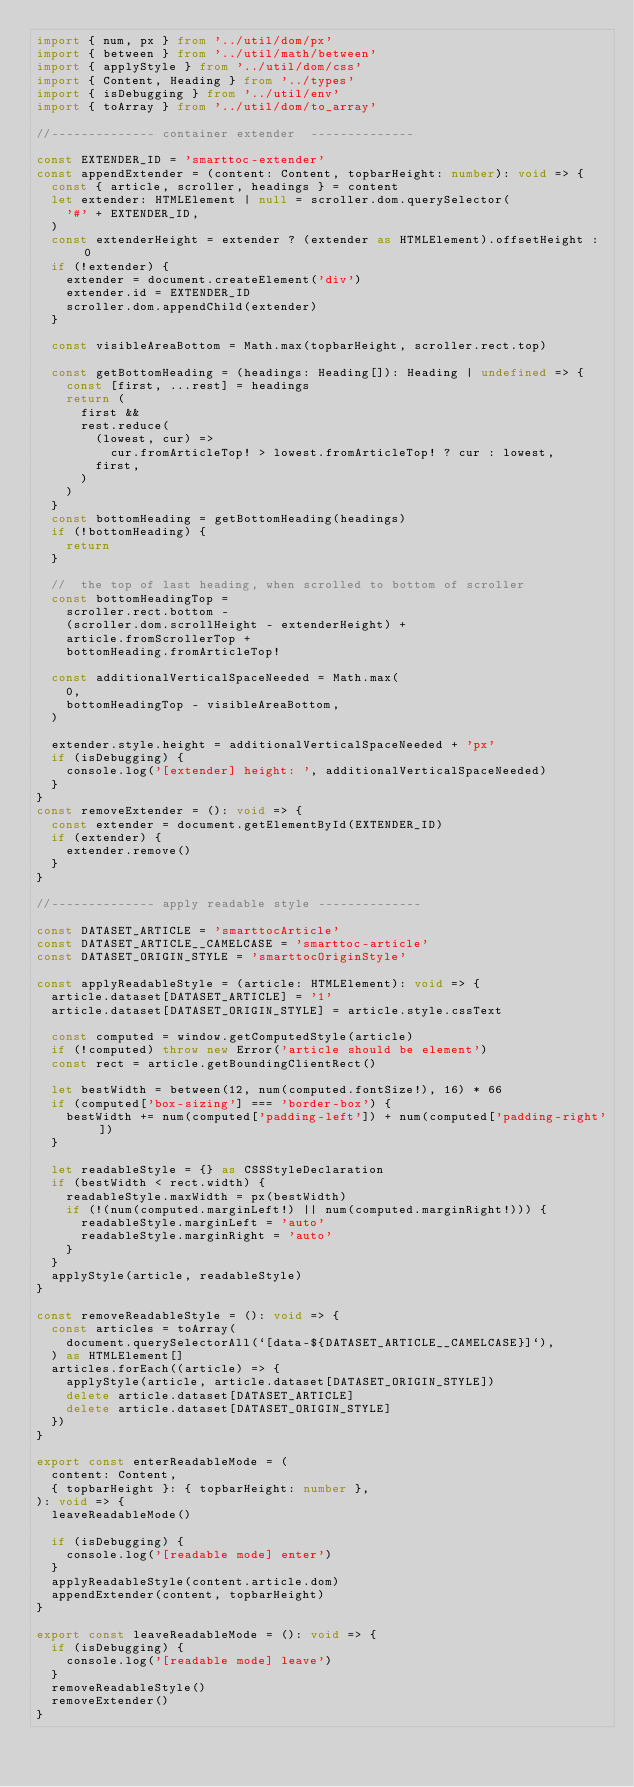Convert code to text. <code><loc_0><loc_0><loc_500><loc_500><_TypeScript_>import { num, px } from '../util/dom/px'
import { between } from '../util/math/between'
import { applyStyle } from '../util/dom/css'
import { Content, Heading } from '../types'
import { isDebugging } from '../util/env'
import { toArray } from '../util/dom/to_array'

//-------------- container extender  --------------

const EXTENDER_ID = 'smarttoc-extender'
const appendExtender = (content: Content, topbarHeight: number): void => {
  const { article, scroller, headings } = content
  let extender: HTMLElement | null = scroller.dom.querySelector(
    '#' + EXTENDER_ID,
  )
  const extenderHeight = extender ? (extender as HTMLElement).offsetHeight : 0
  if (!extender) {
    extender = document.createElement('div')
    extender.id = EXTENDER_ID
    scroller.dom.appendChild(extender)
  }

  const visibleAreaBottom = Math.max(topbarHeight, scroller.rect.top)

  const getBottomHeading = (headings: Heading[]): Heading | undefined => {
    const [first, ...rest] = headings
    return (
      first &&
      rest.reduce(
        (lowest, cur) =>
          cur.fromArticleTop! > lowest.fromArticleTop! ? cur : lowest,
        first,
      )
    )
  }
  const bottomHeading = getBottomHeading(headings)
  if (!bottomHeading) {
    return
  }

  //  the top of last heading, when scrolled to bottom of scroller
  const bottomHeadingTop =
    scroller.rect.bottom -
    (scroller.dom.scrollHeight - extenderHeight) +
    article.fromScrollerTop +
    bottomHeading.fromArticleTop!

  const additionalVerticalSpaceNeeded = Math.max(
    0,
    bottomHeadingTop - visibleAreaBottom,
  )

  extender.style.height = additionalVerticalSpaceNeeded + 'px'
  if (isDebugging) {
    console.log('[extender] height: ', additionalVerticalSpaceNeeded)
  }
}
const removeExtender = (): void => {
  const extender = document.getElementById(EXTENDER_ID)
  if (extender) {
    extender.remove()
  }
}

//-------------- apply readable style --------------

const DATASET_ARTICLE = 'smarttocArticle'
const DATASET_ARTICLE__CAMELCASE = 'smarttoc-article'
const DATASET_ORIGIN_STYLE = 'smarttocOriginStyle'

const applyReadableStyle = (article: HTMLElement): void => {
  article.dataset[DATASET_ARTICLE] = '1'
  article.dataset[DATASET_ORIGIN_STYLE] = article.style.cssText

  const computed = window.getComputedStyle(article)
  if (!computed) throw new Error('article should be element')
  const rect = article.getBoundingClientRect()

  let bestWidth = between(12, num(computed.fontSize!), 16) * 66
  if (computed['box-sizing'] === 'border-box') {
    bestWidth += num(computed['padding-left']) + num(computed['padding-right'])
  }

  let readableStyle = {} as CSSStyleDeclaration
  if (bestWidth < rect.width) {
    readableStyle.maxWidth = px(bestWidth)
    if (!(num(computed.marginLeft!) || num(computed.marginRight!))) {
      readableStyle.marginLeft = 'auto'
      readableStyle.marginRight = 'auto'
    }
  }
  applyStyle(article, readableStyle)
}

const removeReadableStyle = (): void => {
  const articles = toArray(
    document.querySelectorAll(`[data-${DATASET_ARTICLE__CAMELCASE}]`),
  ) as HTMLElement[]
  articles.forEach((article) => {
    applyStyle(article, article.dataset[DATASET_ORIGIN_STYLE])
    delete article.dataset[DATASET_ARTICLE]
    delete article.dataset[DATASET_ORIGIN_STYLE]
  })
}

export const enterReadableMode = (
  content: Content,
  { topbarHeight }: { topbarHeight: number },
): void => {
  leaveReadableMode()

  if (isDebugging) {
    console.log('[readable mode] enter')
  }
  applyReadableStyle(content.article.dom)
  appendExtender(content, topbarHeight)
}

export const leaveReadableMode = (): void => {
  if (isDebugging) {
    console.log('[readable mode] leave')
  }
  removeReadableStyle()
  removeExtender()
}
</code> 